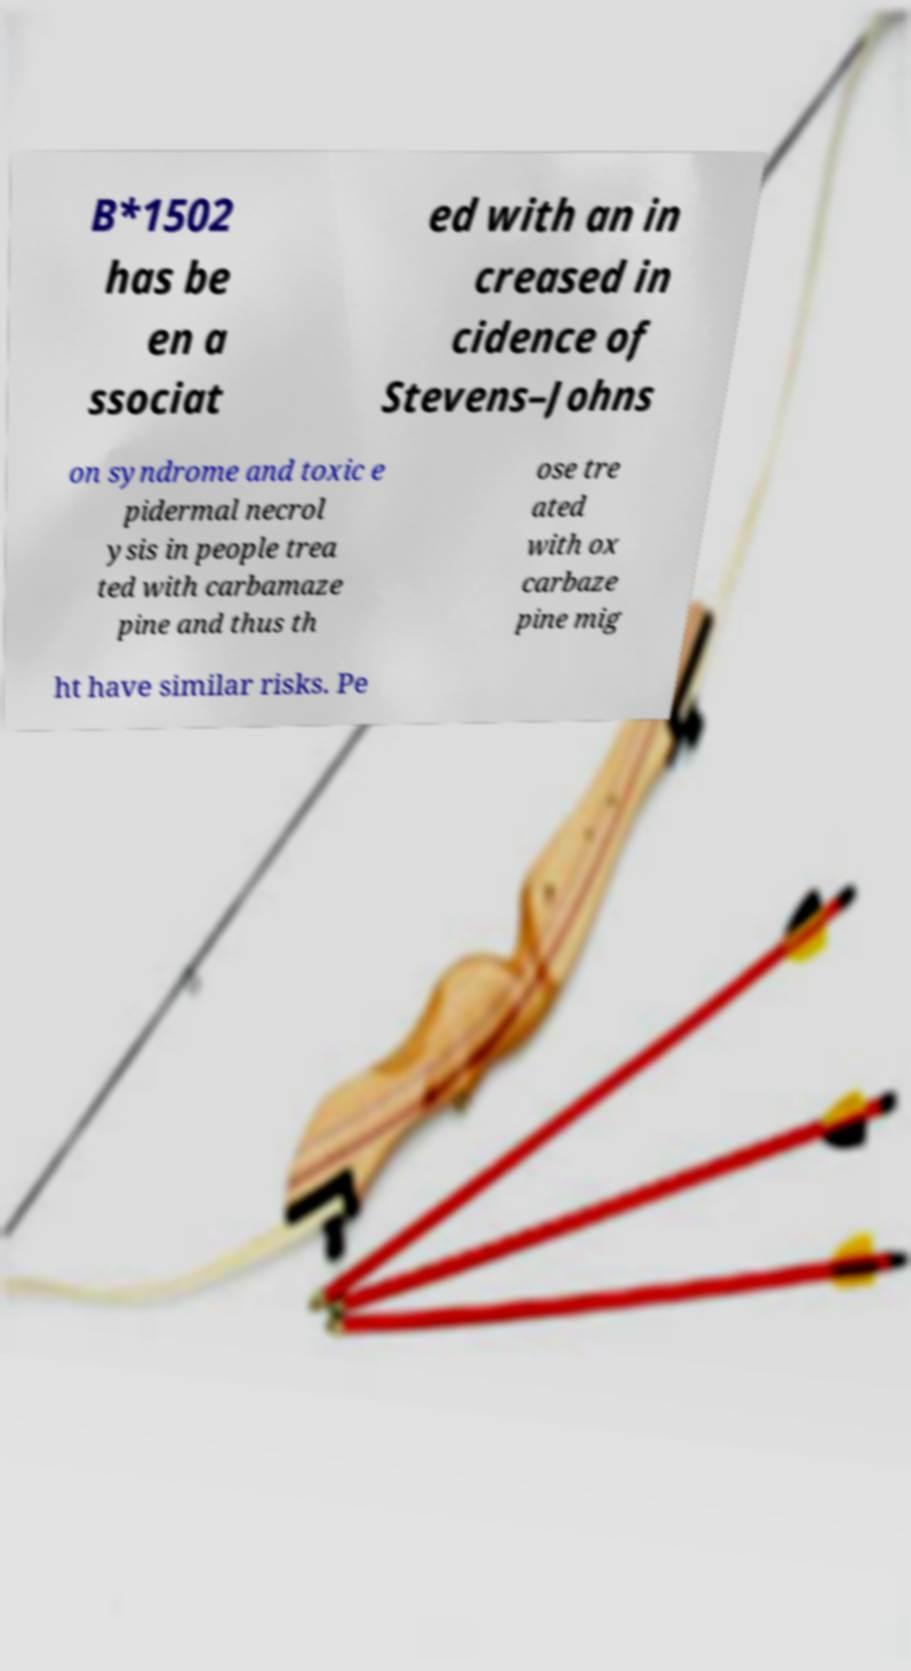Please read and relay the text visible in this image. What does it say? B*1502 has be en a ssociat ed with an in creased in cidence of Stevens–Johns on syndrome and toxic e pidermal necrol ysis in people trea ted with carbamaze pine and thus th ose tre ated with ox carbaze pine mig ht have similar risks. Pe 